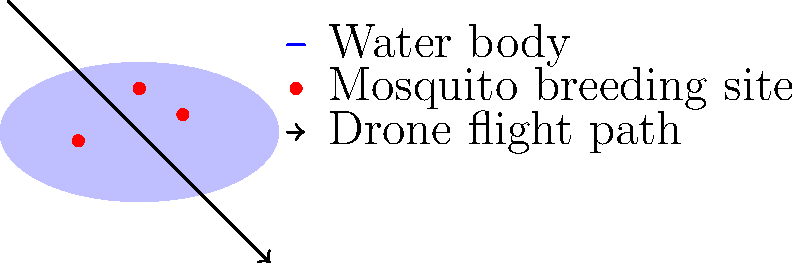Based on the aerial drone imagery of a water body shown above, what is the estimated number of potential mosquito breeding sites detected? To determine the number of potential mosquito breeding sites from the aerial drone imagery, we need to follow these steps:

1. Identify the water body: The large blue elliptical shape represents the water body in the image.

2. Locate red dots: In aerial imagery, potential mosquito breeding sites are often represented by distinct markers or anomalies. In this image, they are shown as red dots.

3. Count the red dots: Carefully examine the water body and count the number of red dots visible within or near its boundaries.

4. Analyze the distribution: Note that the red dots are distributed across different areas of the water body, indicating multiple potential breeding sites.

5. Final count: After careful examination, we can see that there are exactly 3 red dots within the water body.

Each of these red dots represents a potential mosquito breeding site, which could harbor disease-carrying mosquito larvae. As an entomologist, identifying these sites is crucial for implementing targeted vector control measures and reducing the risk of mosquito-borne diseases in the Democratic Republic of Congo.
Answer: 3 